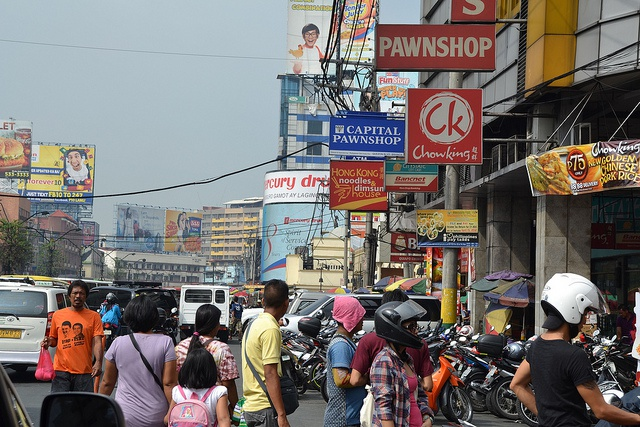Describe the objects in this image and their specific colors. I can see people in lightblue, black, white, darkgray, and brown tones, people in lightblue, darkgray, black, and gray tones, people in lightblue, khaki, black, gray, and tan tones, people in lightblue, black, gray, darkgray, and maroon tones, and people in lightblue, black, red, maroon, and brown tones in this image. 